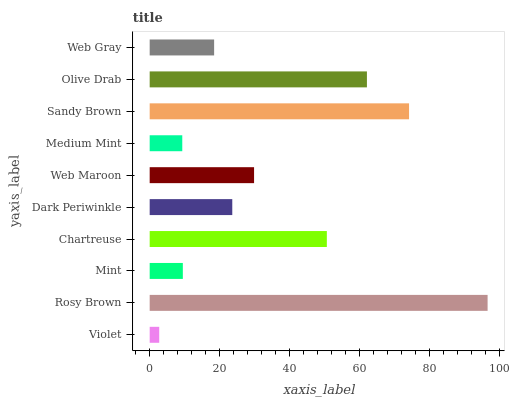Is Violet the minimum?
Answer yes or no. Yes. Is Rosy Brown the maximum?
Answer yes or no. Yes. Is Mint the minimum?
Answer yes or no. No. Is Mint the maximum?
Answer yes or no. No. Is Rosy Brown greater than Mint?
Answer yes or no. Yes. Is Mint less than Rosy Brown?
Answer yes or no. Yes. Is Mint greater than Rosy Brown?
Answer yes or no. No. Is Rosy Brown less than Mint?
Answer yes or no. No. Is Web Maroon the high median?
Answer yes or no. Yes. Is Dark Periwinkle the low median?
Answer yes or no. Yes. Is Sandy Brown the high median?
Answer yes or no. No. Is Web Maroon the low median?
Answer yes or no. No. 